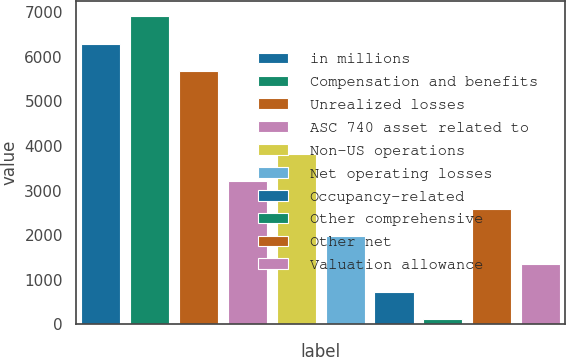Convert chart to OTSL. <chart><loc_0><loc_0><loc_500><loc_500><bar_chart><fcel>in millions<fcel>Compensation and benefits<fcel>Unrealized losses<fcel>ASC 740 asset related to<fcel>Non-US operations<fcel>Net operating losses<fcel>Occupancy-related<fcel>Other comprehensive<fcel>Other net<fcel>Valuation allowance<nl><fcel>6296<fcel>6914.2<fcel>5677.8<fcel>3205<fcel>3823.2<fcel>1968.6<fcel>732.2<fcel>114<fcel>2586.8<fcel>1350.4<nl></chart> 